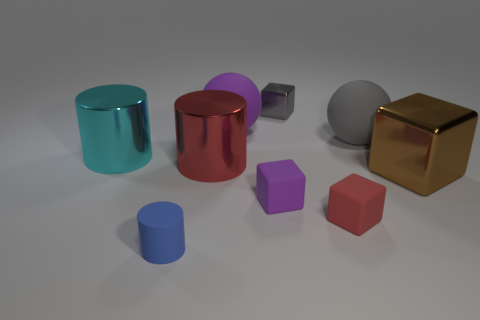There is a big cyan shiny thing; are there any big red metallic objects on the left side of it?
Provide a short and direct response. No. Is there any other thing that is the same size as the purple block?
Your answer should be very brief. Yes. What is the color of the other block that is the same material as the tiny gray block?
Offer a terse response. Brown. There is a ball in front of the big purple rubber ball; is it the same color as the metal block that is right of the red rubber object?
Provide a succinct answer. No. What number of blocks are large brown shiny objects or rubber things?
Make the answer very short. 3. Are there an equal number of small blue rubber objects that are on the right side of the purple ball and small blue rubber objects?
Keep it short and to the point. No. What is the material of the large sphere left of the red thing that is on the right side of the metal cylinder that is on the right side of the blue cylinder?
Your response must be concise. Rubber. There is a large object that is the same color as the small metal block; what is its material?
Offer a terse response. Rubber. How many things are big cylinders that are on the right side of the cyan cylinder or red objects?
Keep it short and to the point. 2. What number of objects are either rubber cylinders or tiny objects that are in front of the big red shiny cylinder?
Your answer should be very brief. 3. 